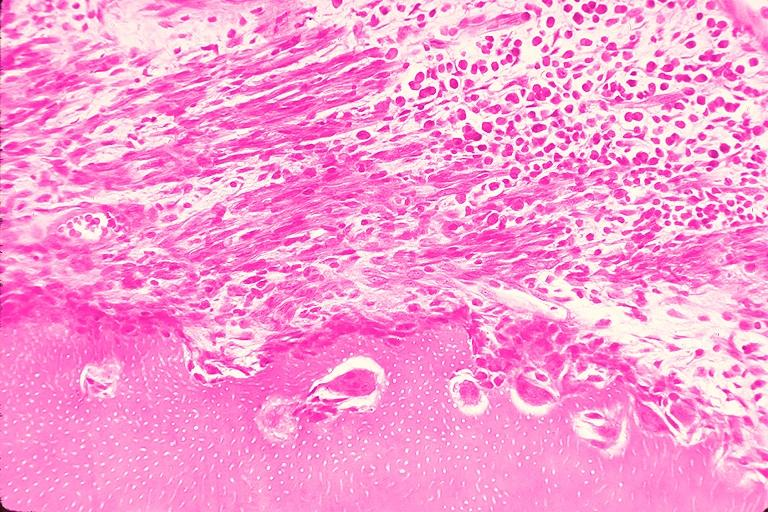does this image show resorption?
Answer the question using a single word or phrase. Yes 